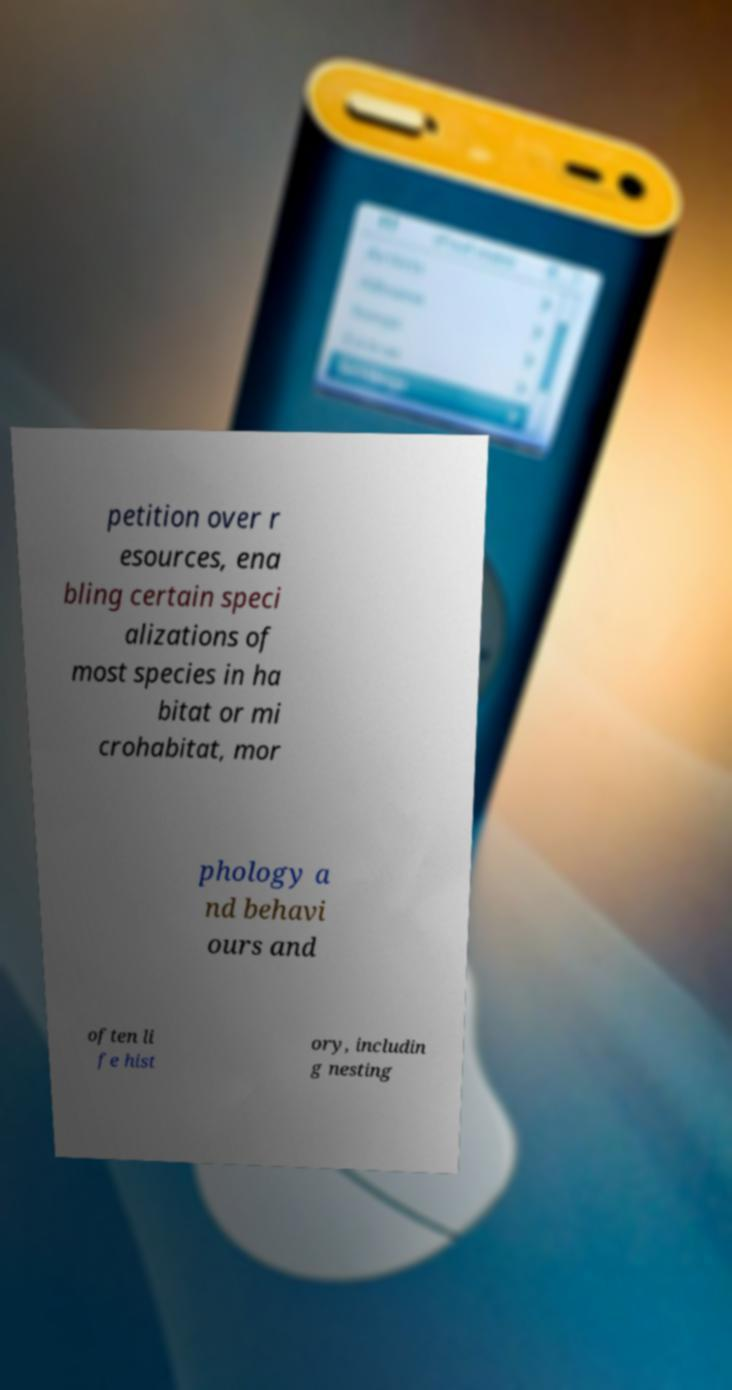Please identify and transcribe the text found in this image. petition over r esources, ena bling certain speci alizations of most species in ha bitat or mi crohabitat, mor phology a nd behavi ours and often li fe hist ory, includin g nesting 